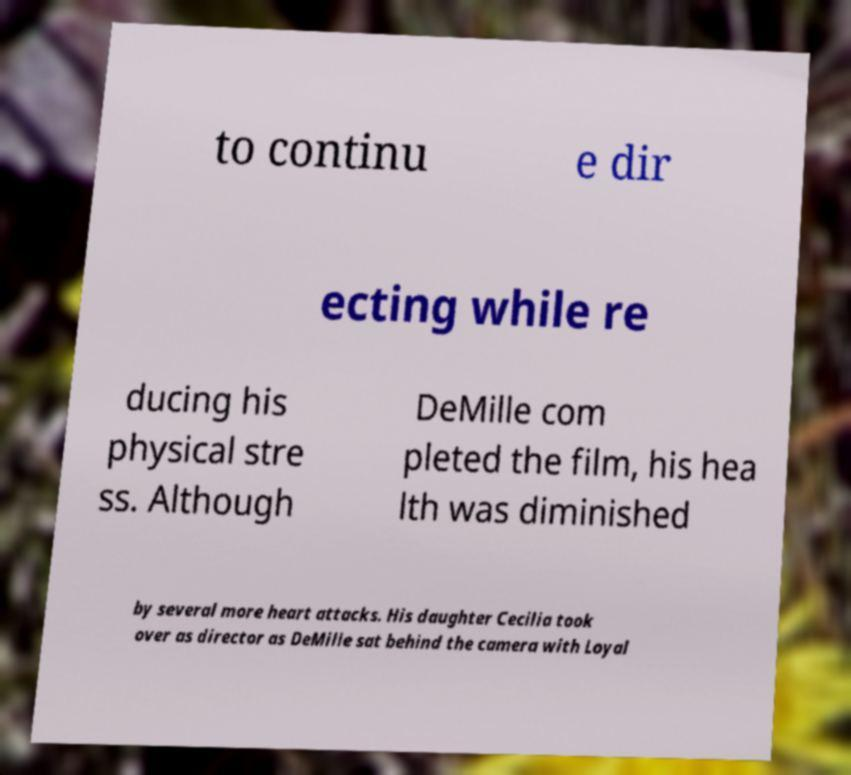Could you assist in decoding the text presented in this image and type it out clearly? to continu e dir ecting while re ducing his physical stre ss. Although DeMille com pleted the film, his hea lth was diminished by several more heart attacks. His daughter Cecilia took over as director as DeMille sat behind the camera with Loyal 